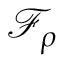<formula> <loc_0><loc_0><loc_500><loc_500>\mathcal { F } _ { \rho }</formula> 